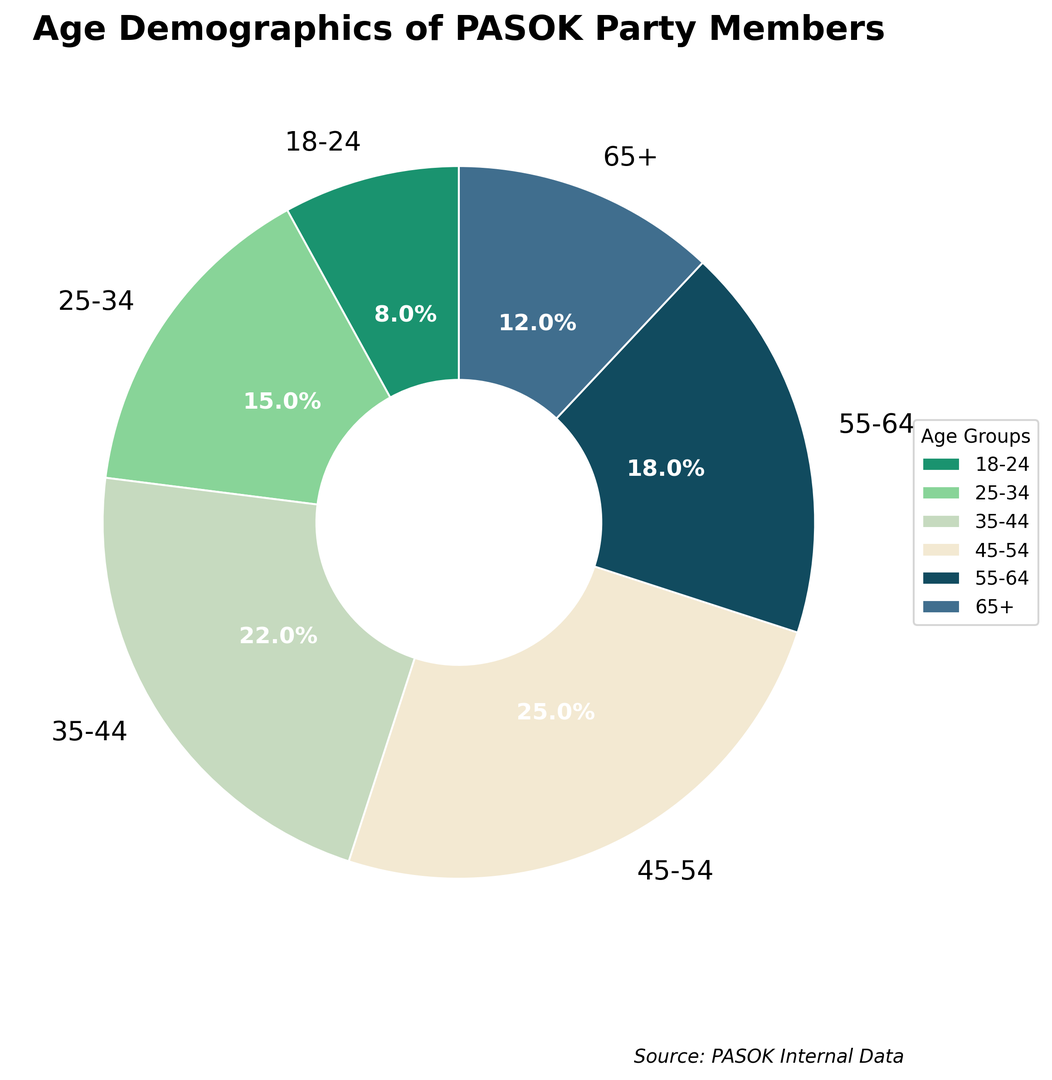What age group has the greatest percentage of PASOK party members? To determine the greatest percentage, we look at the values in the pie chart. The highest percentage is 25% for the age group 45-54.
Answer: 45-54 What age group has the smallest percentage of PASOK party members? To determine the smallest percentage, we look at the values in the pie chart. The lowest percentage is 8% for the age group 18-24.
Answer: 18-24 Which age group has a higher percentage of PASOK party members, 25-34 or 65+? Compare the percentages of 25-34 (15%) and 65+ (12%). 15% is greater than 12%.
Answer: 25-34 What is the combined percentage of PASOK party members aged 35-44 and 55-64? Add the percentages of the 35-44 (22%) and 55-64 (18%) age groups: 22% + 18% = 40%.
Answer: 40% What percentage of PASOK party members are 55 years old or older? Combine the percentages of 55-64 and 65+ age groups: 18% + 12% = 30%.
Answer: 30% How much more or less is the percentage of PASOK party members aged 45-54 compared to 18-24? Subtract the percentage of 18-24 (8%) from 45-54 (25%): 25% - 8% = 17%.
Answer: 17% Is the percentage of PASOK party members aged 25-34 greater than the percentage of those aged 55-64? Compare the percentages of 25-34 (15%) and 55-64 (18%). 15% is less than 18%.
Answer: No Which age group is represented by the green section in the pie chart? Identify the color associated with each age group from the pie chart. The green section (#1A936F) corresponds to the age group 18-24.
Answer: 18-24 What age groups make up less than 20% of the PASOK party members each? Identify the age groups with percentages less than 20%: 18-24 (8%), 25-34 (15%), and 65+ (12%).
Answer: 18-24, 25-34, 65+ What age group representation is roughly equal to the combined percentage of the 18-24 and 25-34 age groups? Combine the percentages of 18-24 (8%) and 25-34 (15%): 8% + 15% = 23%. The 35-44 group has 22%, which is roughly equal to 23%.
Answer: 35-44 